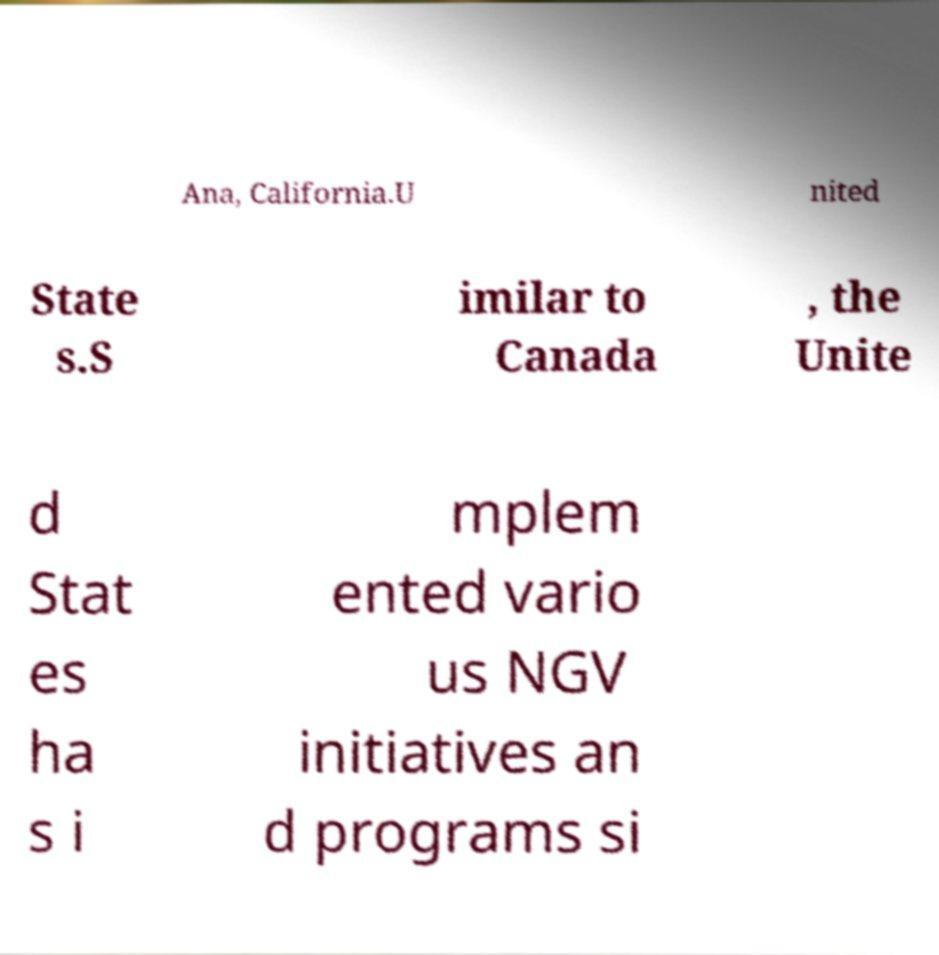Can you read and provide the text displayed in the image?This photo seems to have some interesting text. Can you extract and type it out for me? Ana, California.U nited State s.S imilar to Canada , the Unite d Stat es ha s i mplem ented vario us NGV initiatives an d programs si 